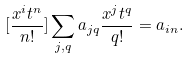<formula> <loc_0><loc_0><loc_500><loc_500>[ \frac { x ^ { i } t ^ { n } } { n ! } ] \sum _ { j , q } a _ { j q } \frac { x ^ { j } t ^ { q } } { q ! } = a _ { i n } .</formula> 